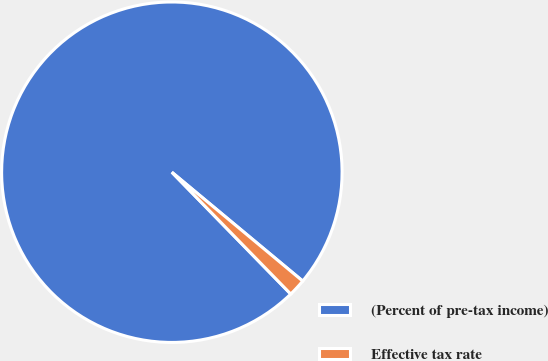Convert chart to OTSL. <chart><loc_0><loc_0><loc_500><loc_500><pie_chart><fcel>(Percent of pre-tax income)<fcel>Effective tax rate<nl><fcel>98.35%<fcel>1.65%<nl></chart> 